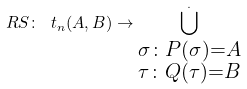Convert formula to latex. <formula><loc_0><loc_0><loc_500><loc_500>R S \colon \ t _ { n } ( A , B ) \rightarrow \bigcup _ { \substack { \sigma \colon P ( \sigma ) = A \\ \tau \colon Q ( \tau ) = B } } ^ { . }</formula> 